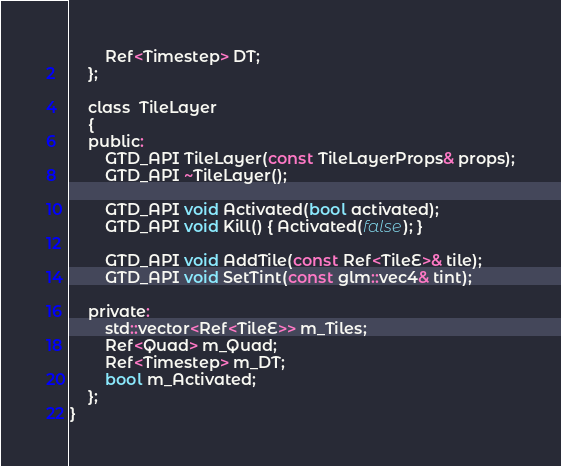Convert code to text. <code><loc_0><loc_0><loc_500><loc_500><_C_>		Ref<Timestep> DT;
	};

	class  TileLayer
	{
	public:
		GTD_API TileLayer(const TileLayerProps& props);
		GTD_API ~TileLayer();

		GTD_API void Activated(bool activated);
		GTD_API void Kill() { Activated(false); }

		GTD_API void AddTile(const Ref<TileE>& tile);
		GTD_API void SetTint(const glm::vec4& tint);

	private:
		std::vector<Ref<TileE>> m_Tiles;
		Ref<Quad> m_Quad;
		Ref<Timestep> m_DT;
		bool m_Activated;
	};
}</code> 